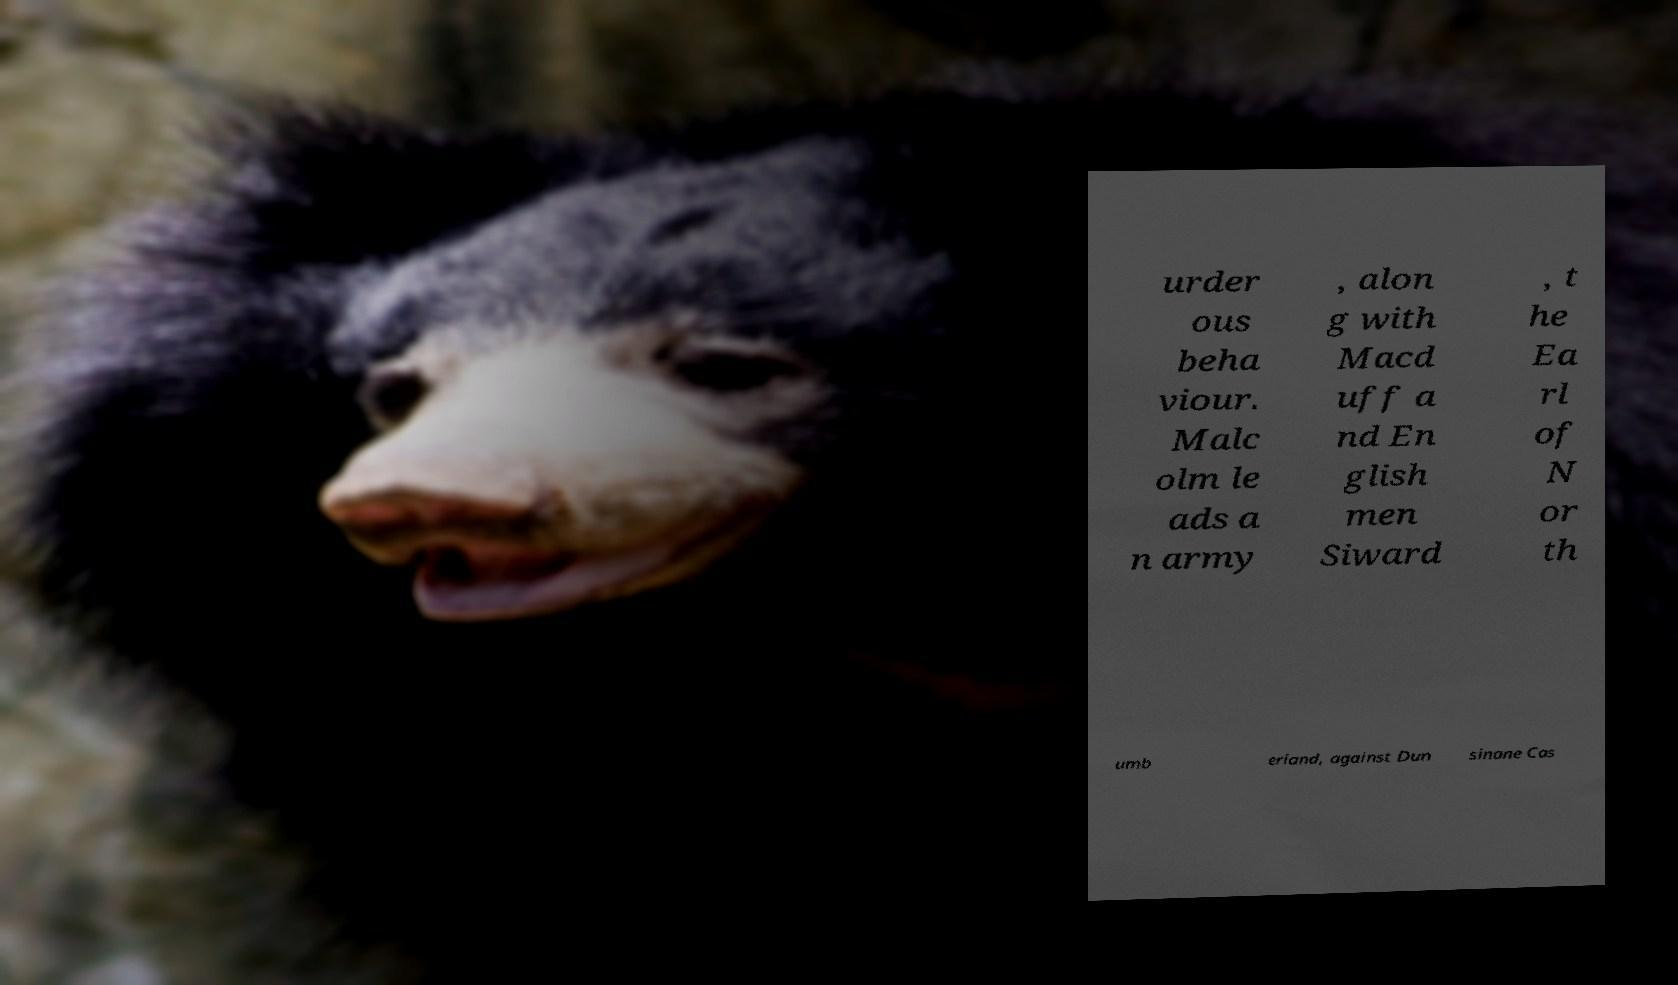Can you accurately transcribe the text from the provided image for me? urder ous beha viour. Malc olm le ads a n army , alon g with Macd uff a nd En glish men Siward , t he Ea rl of N or th umb erland, against Dun sinane Cas 